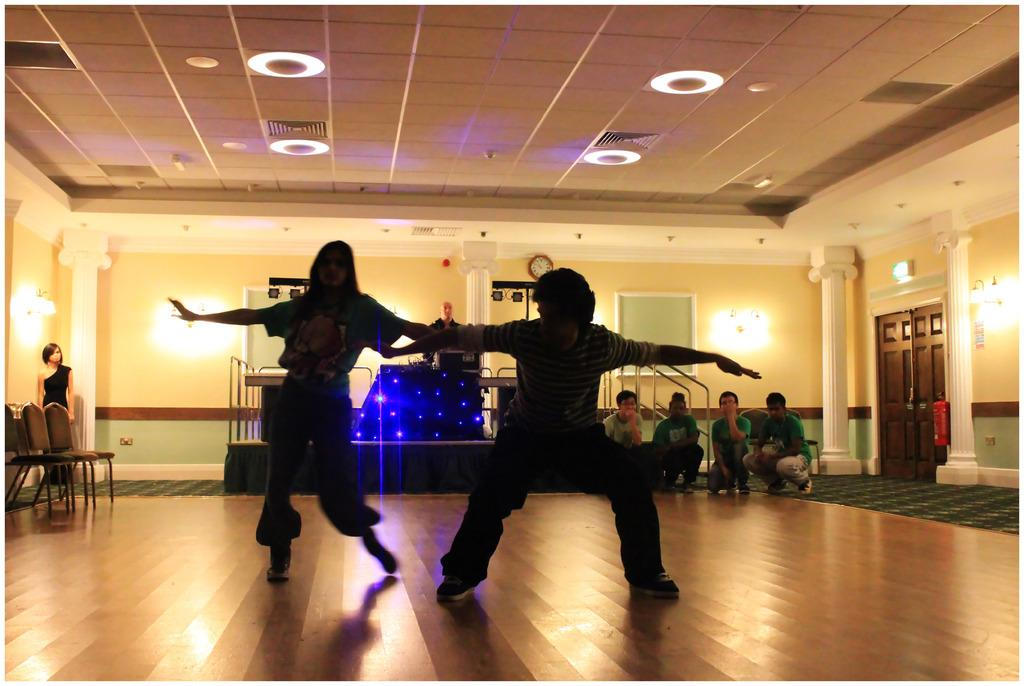How many people are on the floor in the image? There are two people on the floor in the image. What type of furniture can be seen in the image? Chairs are visible in the image. What type of lighting is present in the image? Lights are present in the image. Can you describe the people in the background of the image? There are people in the background of the image. What architectural features are visible in the image? Pillars are visible in the image. What type of entryways are present in the image? Doors are present in the image. What part of the room is visible in the image? The ceiling is visible in the image. What type of enclosure is present in the image? Walls are present in the image. What type of board is visible in the image? There is a board in the image. What time-related object is visible in the image? A clock is visible in the image. What other objects can be seen in the image? There are some objects in the image. Can you see the moon in the image? No, the moon is not present in the image. What type of dinner is being served in the image? There is no dinner being served in the image. 